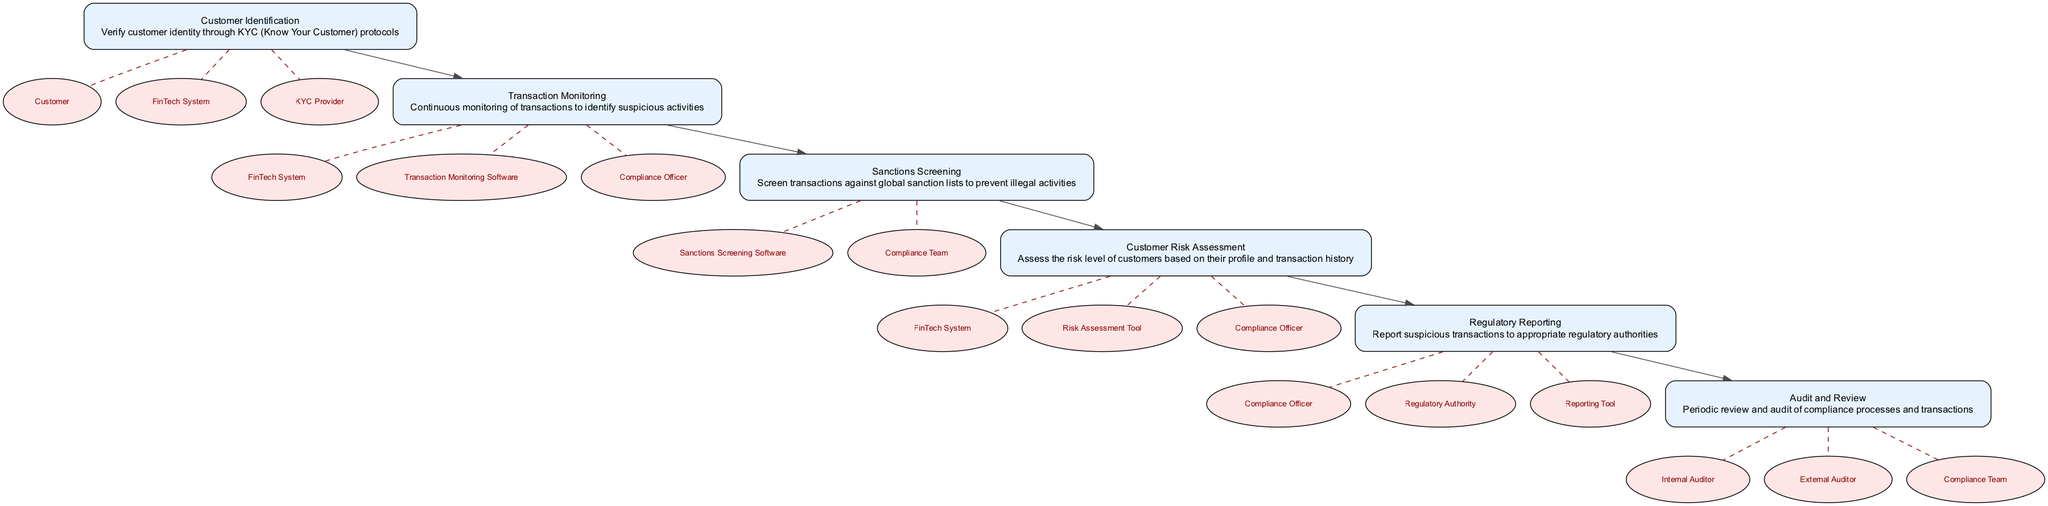What is the first element in the diagram? The first element in the diagram is "Customer Identification". It appears at the top of the workflow and is the starting point for the compliance process by verifying customer identities.
Answer: Customer Identification How many main elements are present in the workflow? There are six main elements in the workflow, as identified by their sequential numbering from 1 to 6. Each element represents a critical stage in the regulatory compliance process.
Answer: Six Which actor is involved in the "Transaction Monitoring" element? The actors involved in "Transaction Monitoring" are the FinTech System, Transaction Monitoring Software, and the Compliance Officer. These actors work together to continuously monitor transactions for suspicious activities.
Answer: FinTech System, Transaction Monitoring Software, Compliance Officer What does the "Sanctions Screening" element aim to achieve? The "Sanctions Screening" element aims to screen transactions against global sanction lists to prevent illegal activities. This ensures that the transactions comply with international regulations.
Answer: Prevent illegal activities Which element follows "Customer Risk Assessment" in the workflow? The element that follows "Customer Risk Assessment" is "Regulatory Reporting". This transition indicates the progression from assessing risk to reporting any suspicious activities identified in previous steps.
Answer: Regulatory Reporting In which step is periodic review and audit conducted? The periodic review and audit are conducted in the "Audit and Review" step. This is a crucial part of the compliance workflow to ensure that the processes and transactions remain effective and compliant.
Answer: Audit and Review What is the primary purpose of "Regulatory Reporting"? The primary purpose of "Regulatory Reporting" is to report suspicious transactions to the appropriate regulatory authorities to ensure compliance with legal requirements.
Answer: Report suspicious transactions Who are the actors involved in the "Audit and Review" process? The actors involved in the "Audit and Review" process are the Internal Auditor, External Auditor, and Compliance Team. These roles ensure a thorough review of compliance processes.
Answer: Internal Auditor, External Auditor, Compliance Team 